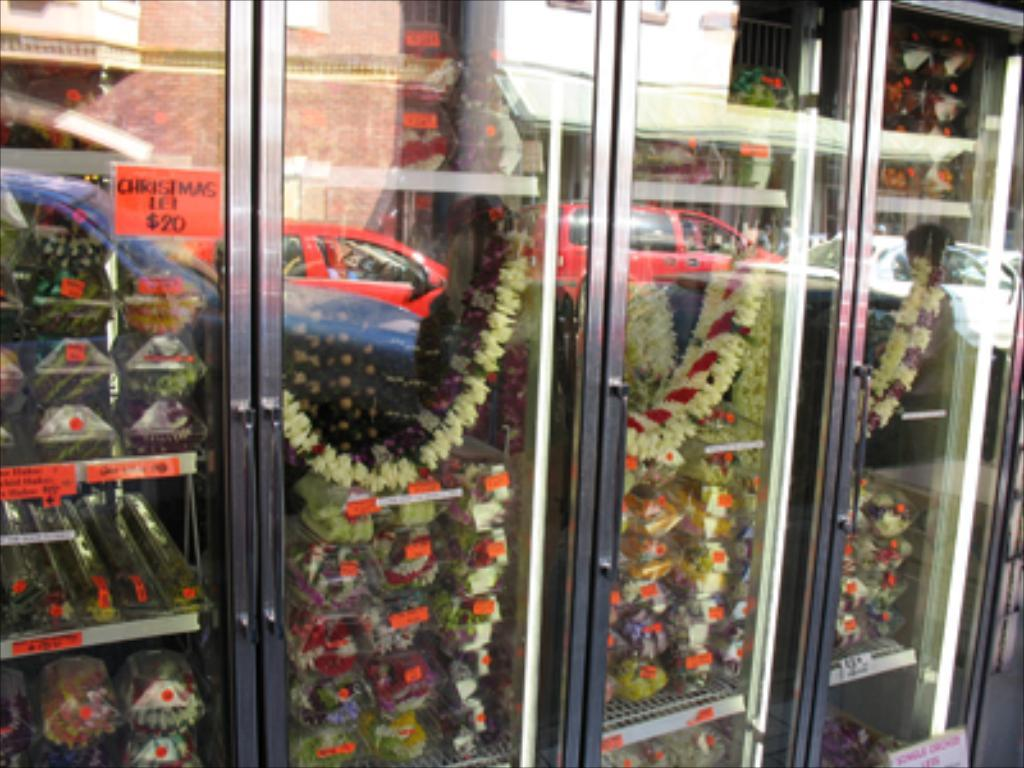What type of furniture is visible in the image? There are cupboards in the image. What is inside the cupboards? There are garlands and other objects inside the cupboards. What can be seen on the surface of the cupboards? There is a reflection of a car and buildings on the cupboards. How many rabbits can be seen playing in the cupboards? There are no rabbits present in the image; it features cupboards with garlands and other objects inside. What action is being performed by the objects inside the cupboards? The objects inside the cupboards are not performing any actions; they are simply stored within the cupboards. 